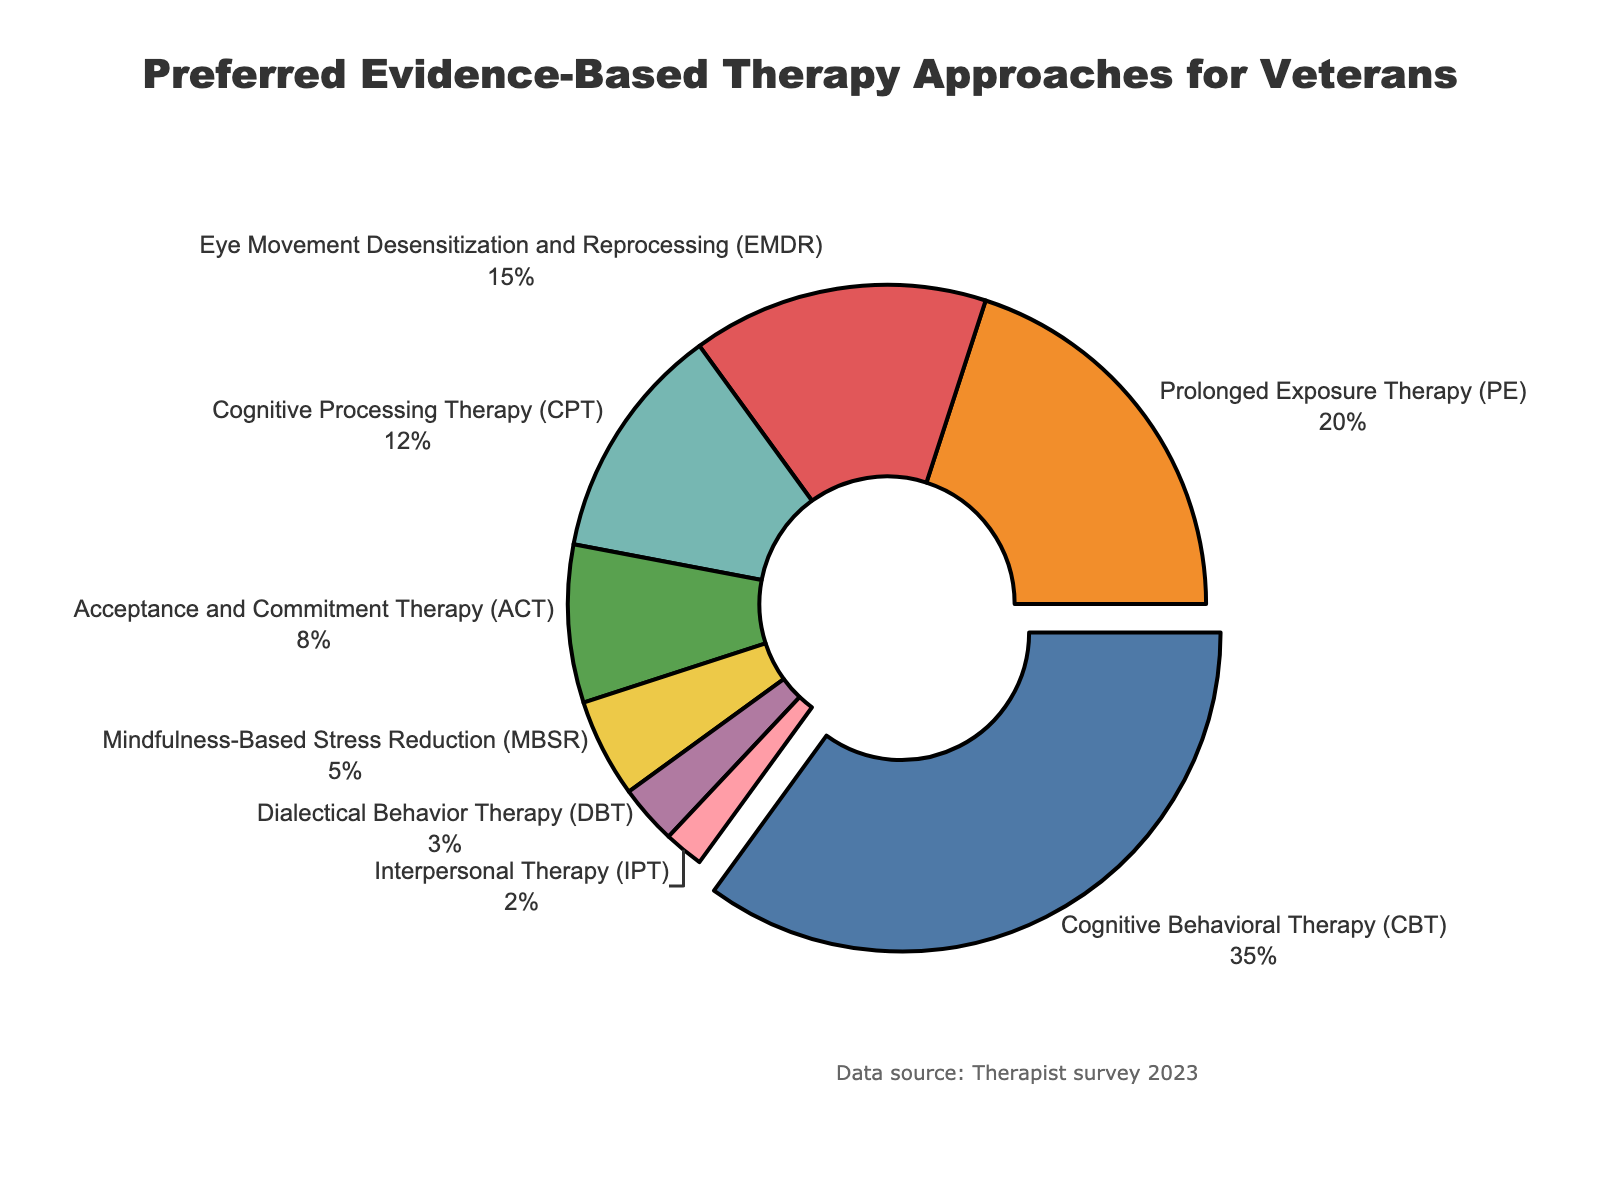What percentage of veterans prefer Cognitive Behavioral Therapy (CBT)? By looking at the pie chart, we see that the slice representing Cognitive Behavioral Therapy (CBT) is labeled with its percentage value.
Answer: 35% How much more popular is Cognitive Behavioral Therapy (CBT) compared to Eye Movement Desensitization and Reprocessing (EMDR)? To determine how much more popular CBT is compared to EMDR, subtract the percentage of EMDR from the percentage of CBT: 35% - 15% = 20%.
Answer: 20% Which therapy approaches have percentages less than 10%? By checking the labels and percentages on the pie chart, we see that Acceptance and Commitment Therapy (ACT), Mindfulness-Based Stress Reduction (MBSR), Dialectical Behavior Therapy (DBT), and Interpersonal Therapy (IPT) all have percentages less than 10%.
Answer: ACT, MBSR, DBT, IPT What is the combined percentage of veterans preferring Prolonged Exposure Therapy (PE) and Cognitive Processing Therapy (CPT)? Add the percentages of PE and CPT together: 20% + 12% = 32%.
Answer: 32% Which therapy approach is the least preferred by veterans? By identifying the smallest slice in the pie chart, we observe that Interpersonal Therapy (IPT) is the least preferred with 2%.
Answer: IPT Compare the popularity of Acceptance and Commitment Therapy (ACT) and Mindfulness-Based Stress Reduction (MBSR). Which one is more preferred? Upon inspecting the pie chart, Acceptance and Commitment Therapy (ACT) has a larger percentage compared to Mindfulness-Based Stress Reduction (MBSR): 8% vs. 5%.
Answer: ACT Identify the therapy approaches with a percentage equal to or greater than 20%. By examining the pie chart, Cognitive Behavioral Therapy (CBT) and Prolonged Exposure Therapy (PE) have percentages equal to or greater than 20%.
Answer: CBT, PE What is the total percentage of the least three preferred therapy approaches? Summing up the percentages of DBT (3%), IPT (2%), and MBSR (5%): 3% + 2% + 5% = 10%.
Answer: 10% What visual characteristics help identify the most preferred therapy approach? The most preferred therapy approach, Cognitive Behavioral Therapy (CBT), is visually highlighted by being pulled out slightly from the pie chart and has a prominent label and percentage.
Answer: Highlighted and pulled out, label 35% Compare the combined percentage of Eye Movement Desensitization and Reprocessing (EMDR) and Cognitive Processing Therapy (CPT) to Cognitive Behavioral Therapy (CBT). Add the percentages of EMDR and CPT together first: 15% + 12% = 27%. Then compare it to CBT's percentage: 35% > 27%.
Answer: CBT is more preferred 